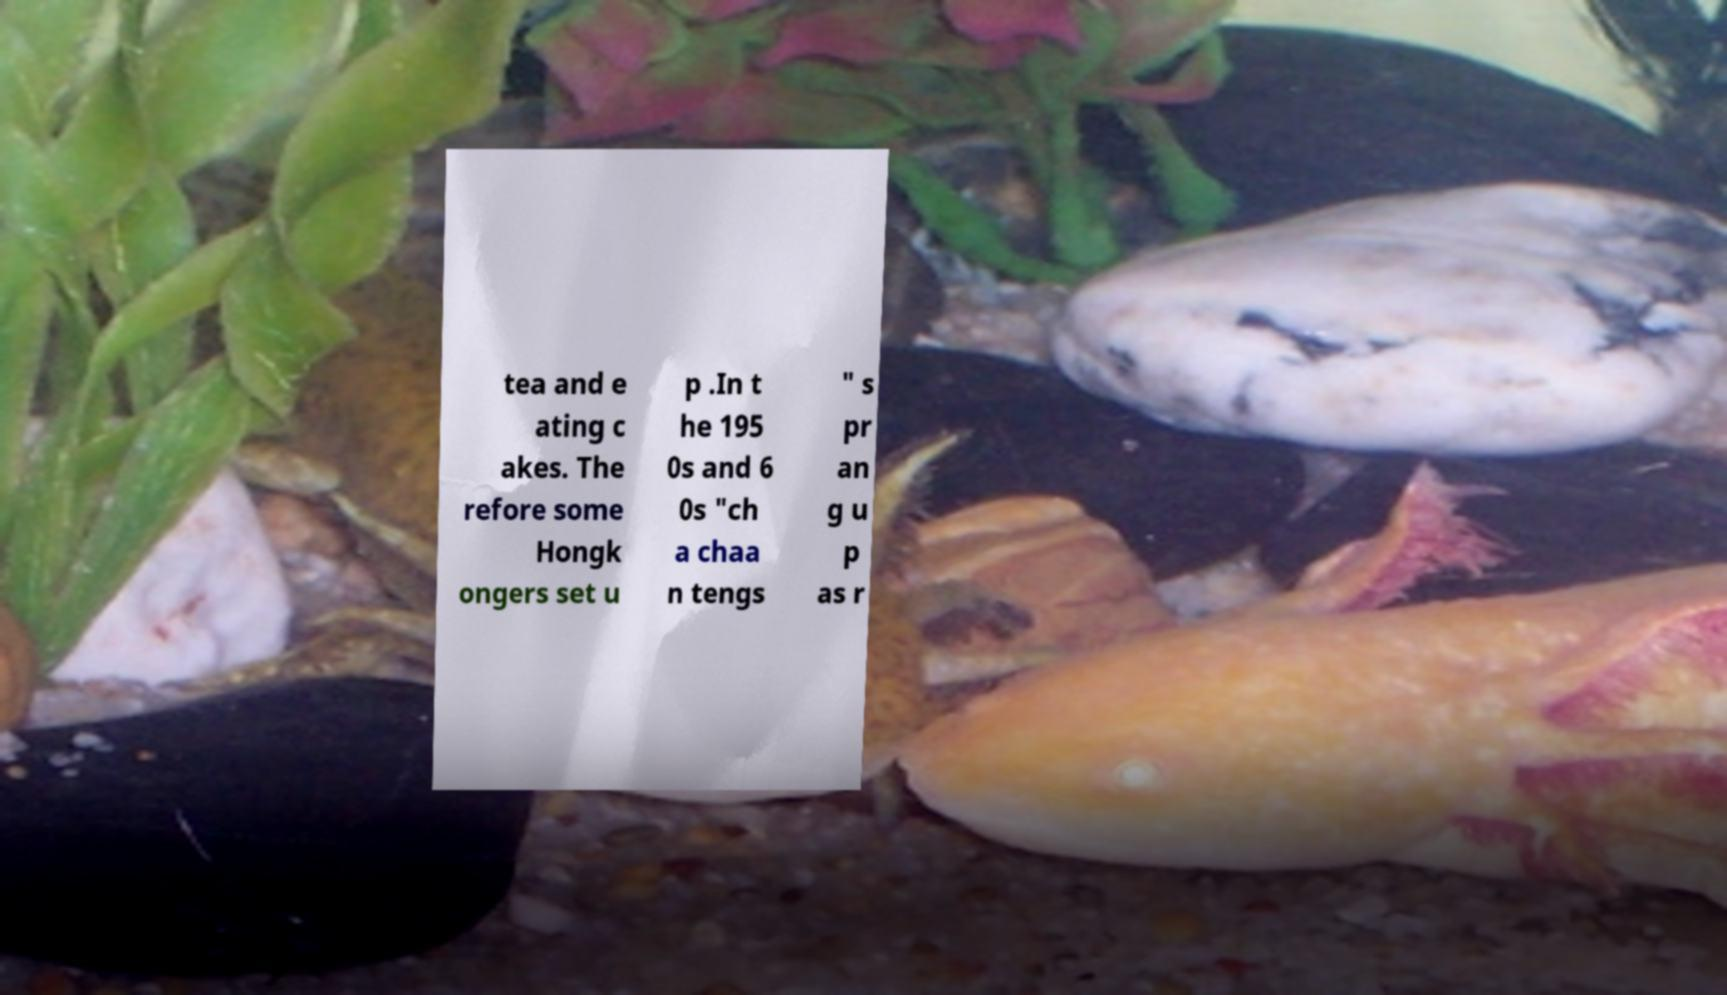There's text embedded in this image that I need extracted. Can you transcribe it verbatim? tea and e ating c akes. The refore some Hongk ongers set u p .In t he 195 0s and 6 0s "ch a chaa n tengs " s pr an g u p as r 